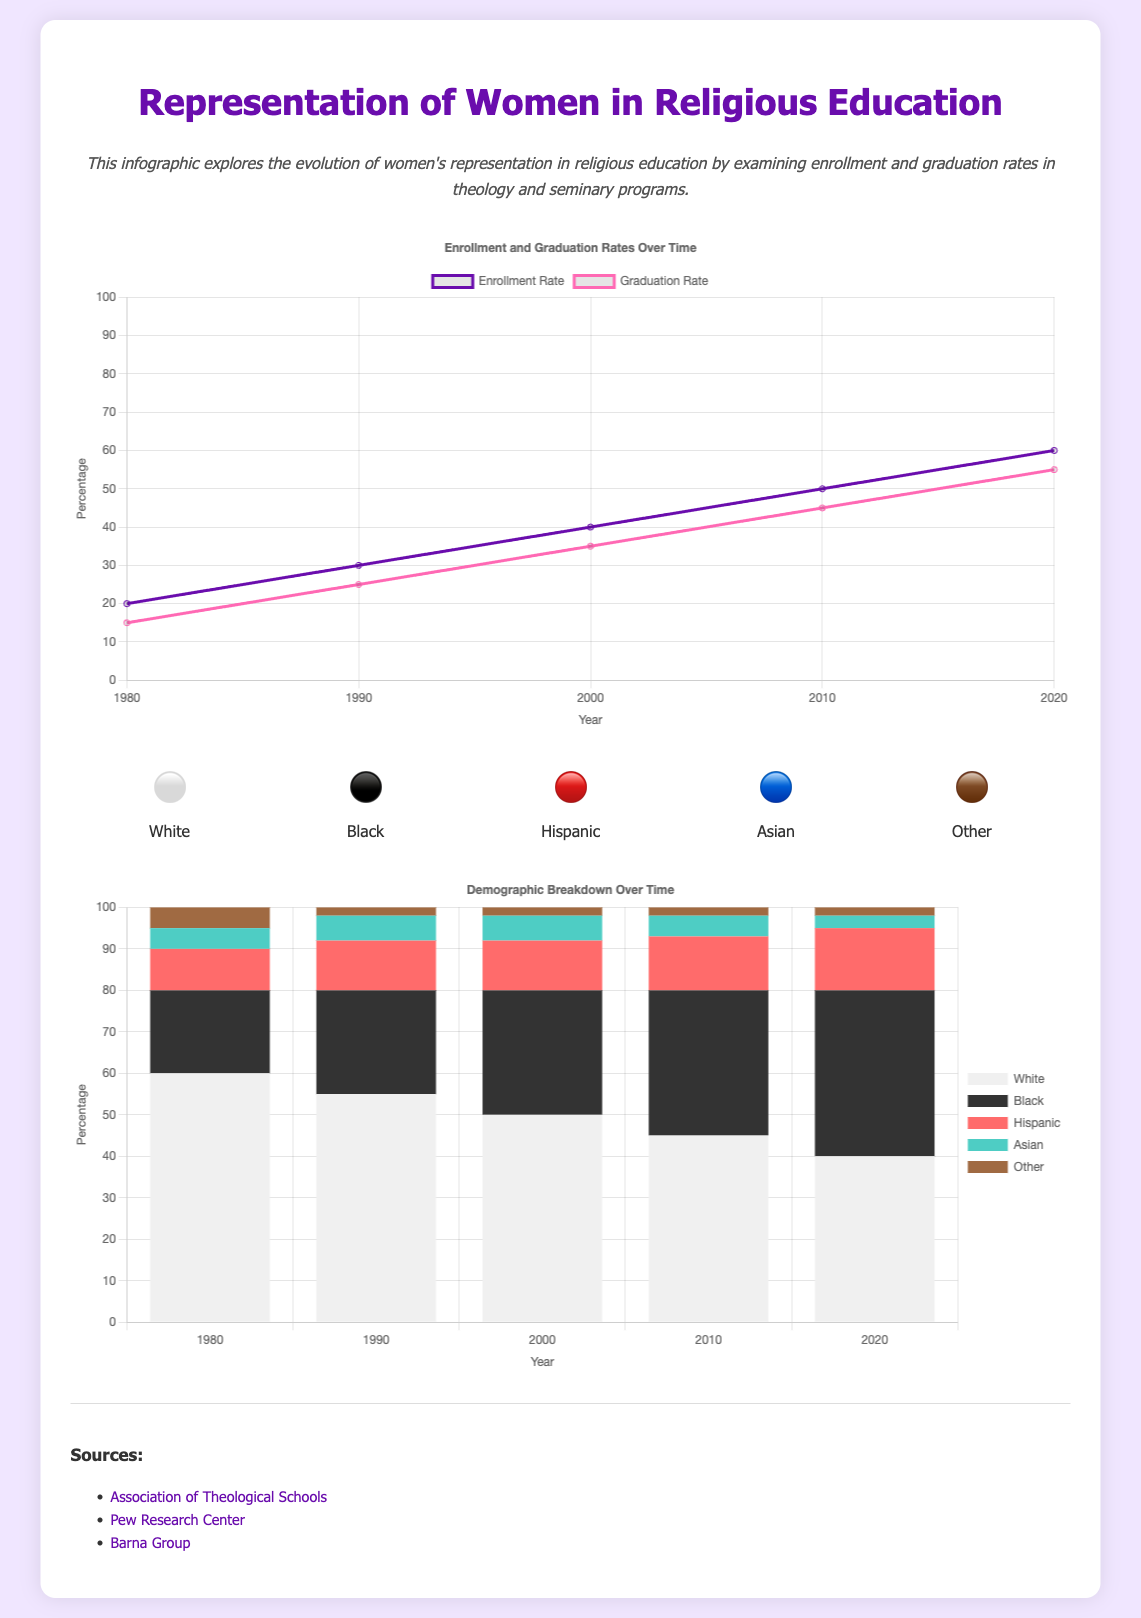what was the enrollment rate in 2020? The enrollment rate in 2020 is shown on the line graph, corresponding to the year 2020.
Answer: 60 what was the graduation rate in 1980? The graduation rate for 1980 can be found on the line graph, indicating the percentage for that year.
Answer: 15 which demographic has the lowest representation in 2020? The demographic chart indicates the percentages of each demographic in 2020, revealing which group has the least representation.
Answer: Asian what is the trend of female enrollment rates from 1980 to 2020? By examining the line graph, we can see the progress of enrollment rates over the years.
Answer: Increasing how many Hispanic students were enrolled in 2010? The bar chart shows the specific percentage for Hispanic students in the year 2010.
Answer: 13 which demographic group saw an increase from 1980 to 2020? Observing the bar chart across the years will show which demographic has increased its representation.
Answer: Black what is the total number of demographics represented in the chart? The demographics section lists various groups visually with symbols, indicating the total count shown.
Answer: 5 what percentage of female students graduated in 2010? The graduation rate for the year 2010 is specified on the line graph, showing the relevant percentage for that year.
Answer: 45 